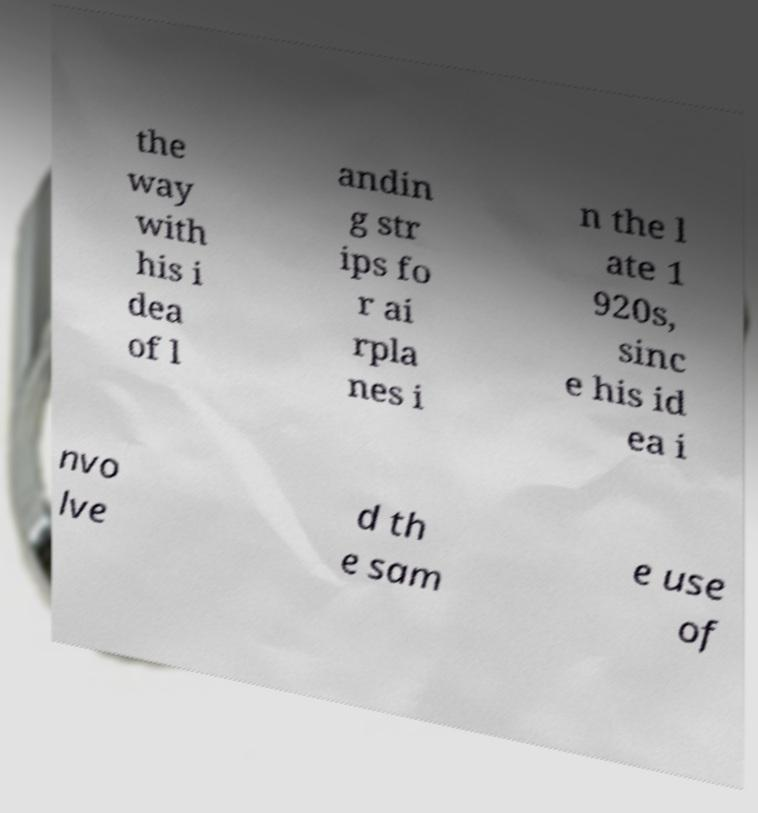Could you assist in decoding the text presented in this image and type it out clearly? the way with his i dea of l andin g str ips fo r ai rpla nes i n the l ate 1 920s, sinc e his id ea i nvo lve d th e sam e use of 